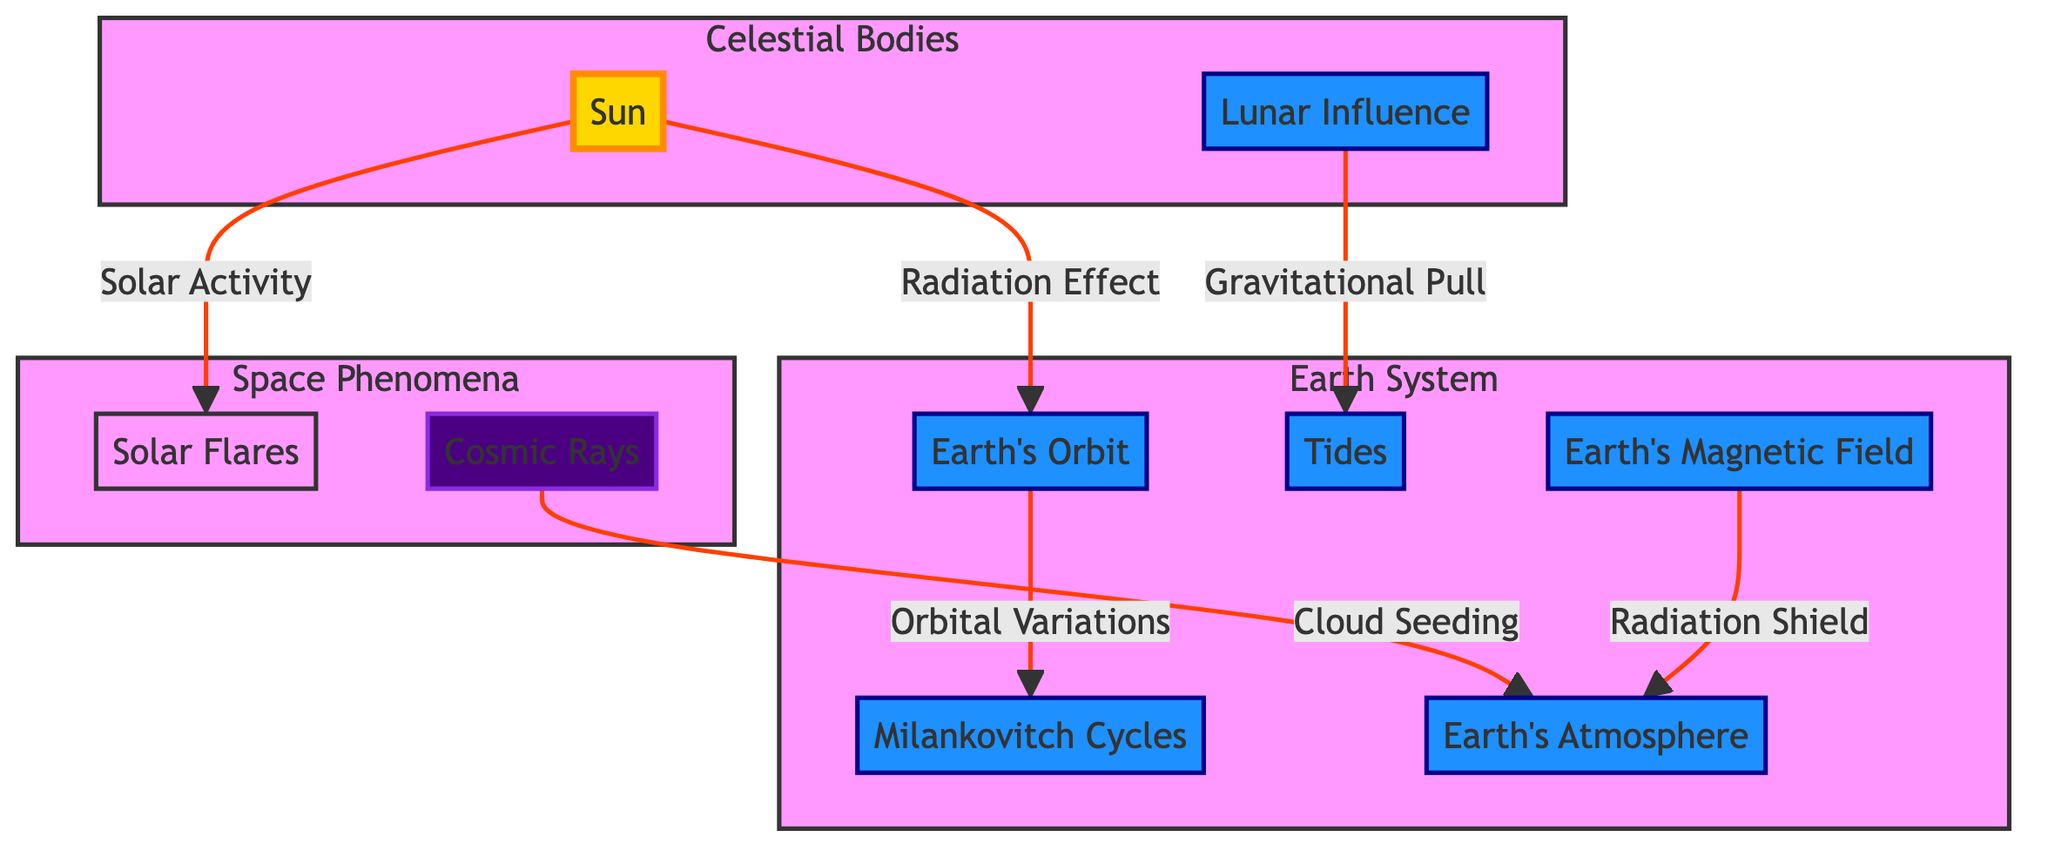What celestial body influences tidal forces on Earth? The diagram indicates that the Lunar Influence exerts a gravitational pull that leads to Tidal Forces. By locating the Lunar Influence node, we see it directly connects to the Tidal Forces node.
Answer: Lunar Influence How many nodes are present in the Earth System subgraph? Counting the nodes within the Earth System subgraph, we identify five elements: Earth's Orbit, Milankovitch Cycles, Tidal Forces, Earth's Magnetic Field, and Earth's Atmosphere. Therefore, the total number of nodes is five.
Answer: 5 What is the relationship between the Sun and Solar Flares? The diagram clearly depicts that the Sun generates Solar Activity, which is linked to the Solar Flares node. The arrow from the Sun to Solar Flares denotes this relationship.
Answer: Solar Activity What effect does Cosmic Rays have on the Earth's Atmosphere? The Cosmic Rays node is connected to the Earth's Atmosphere node through the label "Cloud Seeding". This indicates that Cosmic Rays influence the atmosphere by seeding clouds, which can affect climate patterns.
Answer: Cloud Seeding Which phenomenon acts as a radiation shield for Earth's atmosphere? The diagram shows that the Earth's Magnetic Field node is linked to the Earth's Atmosphere with the label "Radiation Shield". Thus, it functions as a protective shield against radiation in the atmosphere.
Answer: Earth's Magnetic Field What influences does the Sun have on Earth’s Orbit? The diagram indicates that the Sun's radiation effect leads to variations in Earth's Orbit. Understanding that the Sun provides this effect helps us see the direct connection between solar influence and Earth's orbital changes.
Answer: Radiation Effect How do Milankovitch Cycles relate to Earth's Orbit? The relationship is depicted by an arrow from Earth's Orbit to Milankovitch Cycles labeled "Orbital Variations". This indicates that variations in Earth's Orbit influence Milankovitch Cycles, which are longer-term climate changes.
Answer: Orbital Variations What is the role of Tidal Forces in relation to Lunar Influence? The diagram shows that Tidal Forces are directly influenced by the Lunar Influence through a label indicating "Gravitational Pull". This signifies how the Moon's gravitational effect creates tidal changes on Earth.
Answer: Gravitational Pull 